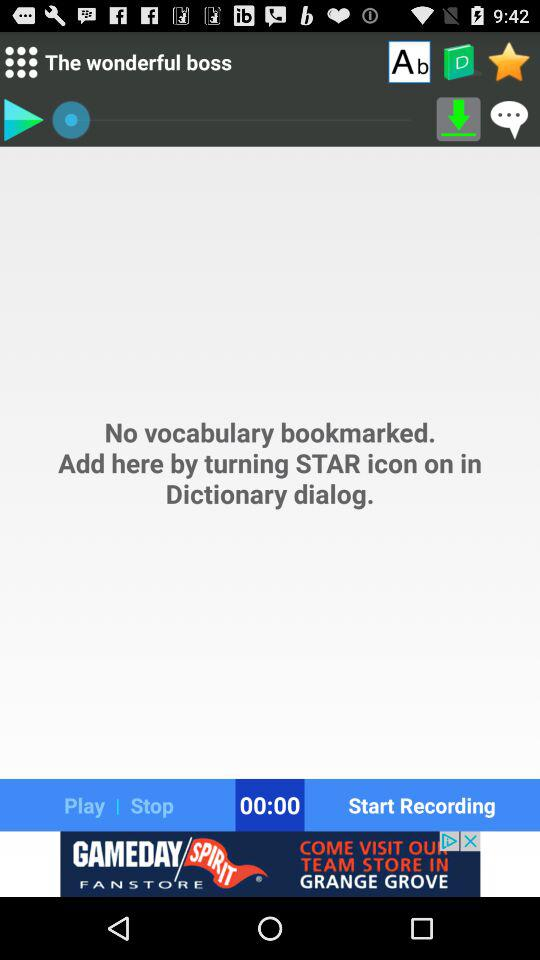What is the mentioned duration? The mentioned duration is 00:00. 